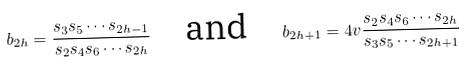Convert formula to latex. <formula><loc_0><loc_0><loc_500><loc_500>b _ { 2 h } = \frac { s _ { 3 } s _ { 5 } \cdots s _ { 2 h - 1 } } { s _ { 2 } s _ { 4 } s _ { 6 } \cdots s _ { 2 h } } \quad \text {and} \quad b _ { 2 h + 1 } = 4 v \frac { s _ { 2 } s _ { 4 } s _ { 6 } \cdots s _ { 2 h } } { s _ { 3 } s _ { 5 } \cdots s _ { 2 h + 1 } }</formula> 